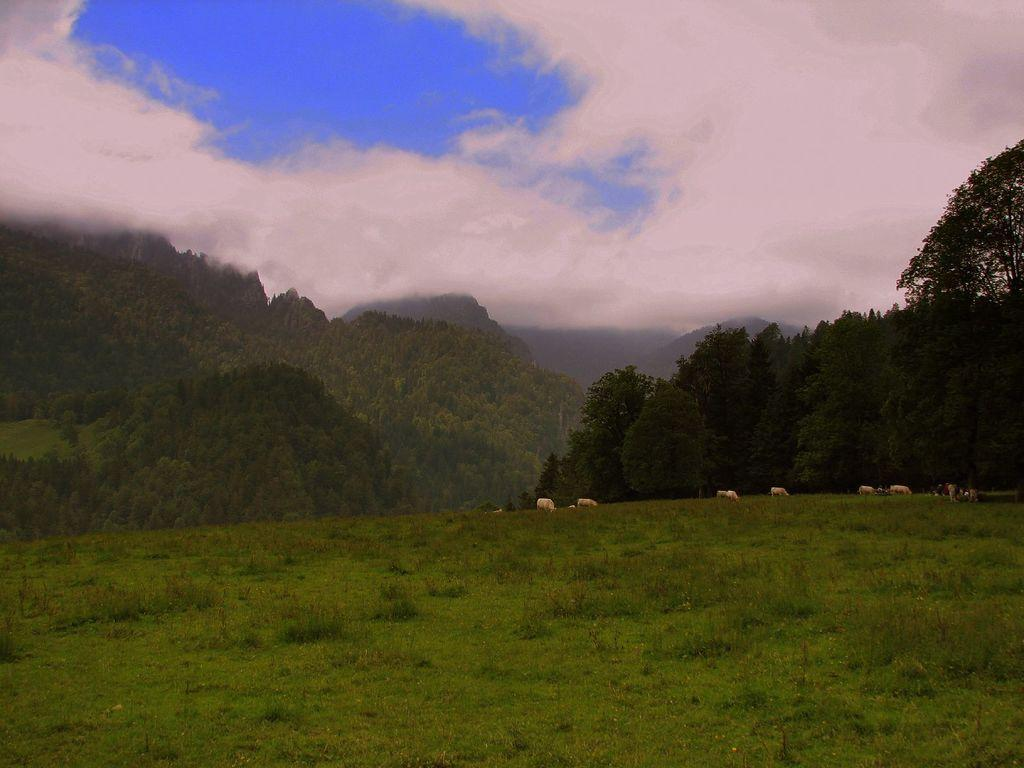What animals can be seen in the image? There are cattle grazing in the image. What are the cattle doing in the image? The cattle are grazing on grass. What type of vegetation is present in the image? There are trees in the image. What type of landscape can be seen in the image? There are hills in the image. What is visible in the sky in the image? The sky is visible in the image, and clouds are present. What type of sack is being used by the spy in the image? There is no sack or spy present in the image; it features cattle grazing on grass with trees, hills, and clouds in the sky. 